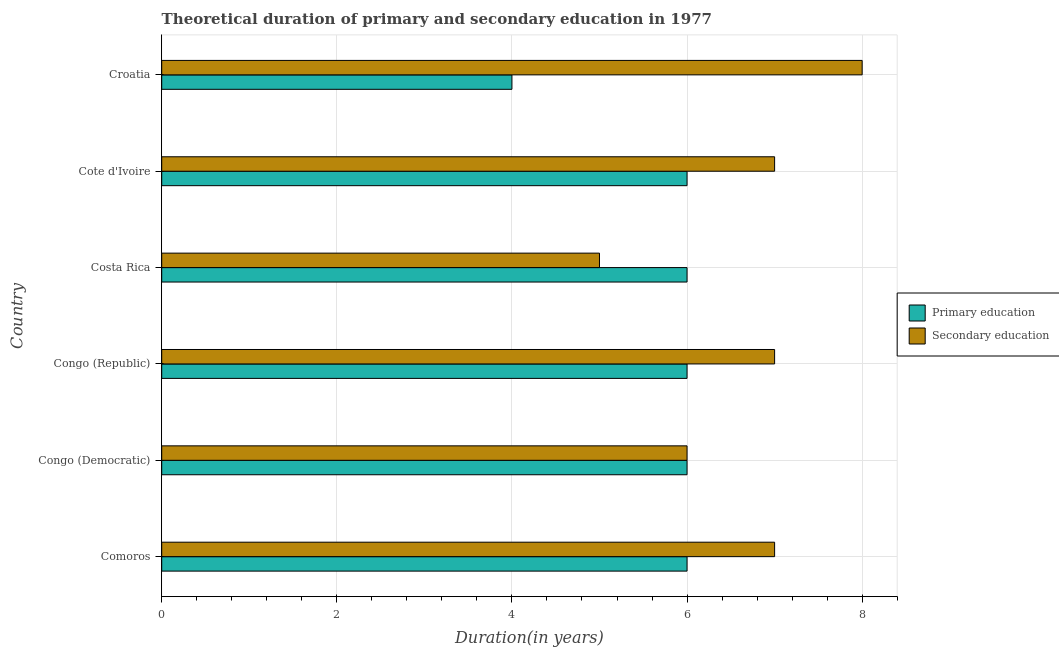How many different coloured bars are there?
Your answer should be compact. 2. How many groups of bars are there?
Offer a very short reply. 6. Are the number of bars per tick equal to the number of legend labels?
Your answer should be very brief. Yes. Are the number of bars on each tick of the Y-axis equal?
Give a very brief answer. Yes. How many bars are there on the 5th tick from the bottom?
Your answer should be compact. 2. What is the label of the 2nd group of bars from the top?
Ensure brevity in your answer.  Cote d'Ivoire. What is the duration of secondary education in Congo (Republic)?
Give a very brief answer. 7. Across all countries, what is the maximum duration of primary education?
Offer a terse response. 6. Across all countries, what is the minimum duration of primary education?
Offer a terse response. 4. In which country was the duration of primary education maximum?
Keep it short and to the point. Comoros. In which country was the duration of secondary education minimum?
Your response must be concise. Costa Rica. What is the total duration of secondary education in the graph?
Offer a very short reply. 40. What is the difference between the duration of primary education in Congo (Democratic) and that in Costa Rica?
Offer a terse response. 0. What is the difference between the duration of secondary education in Costa Rica and the duration of primary education in Croatia?
Provide a short and direct response. 1. What is the average duration of primary education per country?
Your answer should be very brief. 5.67. What is the difference between the duration of secondary education and duration of primary education in Costa Rica?
Ensure brevity in your answer.  -1. In how many countries, is the duration of secondary education greater than 2.8 years?
Provide a succinct answer. 6. Is the difference between the duration of primary education in Congo (Republic) and Cote d'Ivoire greater than the difference between the duration of secondary education in Congo (Republic) and Cote d'Ivoire?
Ensure brevity in your answer.  No. What is the difference between the highest and the second highest duration of secondary education?
Provide a short and direct response. 1. What is the difference between the highest and the lowest duration of primary education?
Provide a short and direct response. 2. What does the 1st bar from the top in Comoros represents?
Provide a short and direct response. Secondary education. How many bars are there?
Your answer should be compact. 12. What is the difference between two consecutive major ticks on the X-axis?
Your answer should be compact. 2. Does the graph contain any zero values?
Provide a short and direct response. No. Does the graph contain grids?
Make the answer very short. Yes. Where does the legend appear in the graph?
Provide a short and direct response. Center right. What is the title of the graph?
Offer a very short reply. Theoretical duration of primary and secondary education in 1977. What is the label or title of the X-axis?
Ensure brevity in your answer.  Duration(in years). What is the Duration(in years) in Primary education in Comoros?
Give a very brief answer. 6. What is the Duration(in years) of Primary education in Congo (Republic)?
Provide a succinct answer. 6. What is the Duration(in years) of Secondary education in Congo (Republic)?
Offer a terse response. 7. What is the Duration(in years) of Secondary education in Costa Rica?
Offer a terse response. 5. What is the Duration(in years) in Primary education in Cote d'Ivoire?
Your response must be concise. 6. What is the Duration(in years) of Secondary education in Cote d'Ivoire?
Make the answer very short. 7. What is the Duration(in years) of Primary education in Croatia?
Your answer should be compact. 4. What is the Duration(in years) of Secondary education in Croatia?
Your answer should be very brief. 8. Across all countries, what is the maximum Duration(in years) of Secondary education?
Offer a terse response. 8. Across all countries, what is the minimum Duration(in years) of Primary education?
Your answer should be compact. 4. What is the difference between the Duration(in years) in Primary education in Comoros and that in Congo (Democratic)?
Offer a very short reply. 0. What is the difference between the Duration(in years) in Secondary education in Comoros and that in Congo (Democratic)?
Make the answer very short. 1. What is the difference between the Duration(in years) of Primary education in Comoros and that in Costa Rica?
Give a very brief answer. 0. What is the difference between the Duration(in years) of Primary education in Comoros and that in Cote d'Ivoire?
Your answer should be compact. 0. What is the difference between the Duration(in years) in Secondary education in Comoros and that in Cote d'Ivoire?
Keep it short and to the point. 0. What is the difference between the Duration(in years) in Secondary education in Comoros and that in Croatia?
Provide a succinct answer. -1. What is the difference between the Duration(in years) in Primary education in Congo (Democratic) and that in Congo (Republic)?
Provide a succinct answer. 0. What is the difference between the Duration(in years) in Secondary education in Congo (Democratic) and that in Congo (Republic)?
Make the answer very short. -1. What is the difference between the Duration(in years) in Secondary education in Congo (Democratic) and that in Costa Rica?
Offer a very short reply. 1. What is the difference between the Duration(in years) of Primary education in Congo (Democratic) and that in Cote d'Ivoire?
Provide a succinct answer. 0. What is the difference between the Duration(in years) in Secondary education in Congo (Democratic) and that in Cote d'Ivoire?
Offer a terse response. -1. What is the difference between the Duration(in years) of Primary education in Congo (Republic) and that in Costa Rica?
Ensure brevity in your answer.  0. What is the difference between the Duration(in years) of Primary education in Congo (Republic) and that in Cote d'Ivoire?
Ensure brevity in your answer.  0. What is the difference between the Duration(in years) in Secondary education in Congo (Republic) and that in Croatia?
Offer a terse response. -1. What is the difference between the Duration(in years) of Primary education in Costa Rica and that in Cote d'Ivoire?
Provide a succinct answer. 0. What is the difference between the Duration(in years) of Secondary education in Costa Rica and that in Cote d'Ivoire?
Your answer should be very brief. -2. What is the difference between the Duration(in years) in Secondary education in Costa Rica and that in Croatia?
Ensure brevity in your answer.  -3. What is the difference between the Duration(in years) of Secondary education in Cote d'Ivoire and that in Croatia?
Make the answer very short. -1. What is the difference between the Duration(in years) of Primary education in Comoros and the Duration(in years) of Secondary education in Congo (Republic)?
Offer a terse response. -1. What is the difference between the Duration(in years) in Primary education in Comoros and the Duration(in years) in Secondary education in Costa Rica?
Your answer should be very brief. 1. What is the difference between the Duration(in years) of Primary education in Comoros and the Duration(in years) of Secondary education in Croatia?
Offer a terse response. -2. What is the difference between the Duration(in years) in Primary education in Congo (Democratic) and the Duration(in years) in Secondary education in Congo (Republic)?
Give a very brief answer. -1. What is the difference between the Duration(in years) of Primary education in Congo (Democratic) and the Duration(in years) of Secondary education in Costa Rica?
Your answer should be compact. 1. What is the difference between the Duration(in years) of Primary education in Congo (Democratic) and the Duration(in years) of Secondary education in Cote d'Ivoire?
Give a very brief answer. -1. What is the difference between the Duration(in years) in Primary education in Costa Rica and the Duration(in years) in Secondary education in Cote d'Ivoire?
Keep it short and to the point. -1. What is the difference between the Duration(in years) of Primary education in Costa Rica and the Duration(in years) of Secondary education in Croatia?
Make the answer very short. -2. What is the average Duration(in years) in Primary education per country?
Your answer should be very brief. 5.67. What is the average Duration(in years) in Secondary education per country?
Provide a succinct answer. 6.67. What is the difference between the Duration(in years) in Primary education and Duration(in years) in Secondary education in Comoros?
Make the answer very short. -1. What is the difference between the Duration(in years) in Primary education and Duration(in years) in Secondary education in Congo (Democratic)?
Make the answer very short. 0. What is the difference between the Duration(in years) of Primary education and Duration(in years) of Secondary education in Congo (Republic)?
Give a very brief answer. -1. What is the difference between the Duration(in years) of Primary education and Duration(in years) of Secondary education in Costa Rica?
Your response must be concise. 1. What is the difference between the Duration(in years) of Primary education and Duration(in years) of Secondary education in Cote d'Ivoire?
Provide a short and direct response. -1. What is the ratio of the Duration(in years) in Primary education in Comoros to that in Congo (Democratic)?
Keep it short and to the point. 1. What is the ratio of the Duration(in years) of Primary education in Comoros to that in Congo (Republic)?
Offer a very short reply. 1. What is the ratio of the Duration(in years) in Secondary education in Comoros to that in Congo (Republic)?
Offer a terse response. 1. What is the ratio of the Duration(in years) of Secondary education in Comoros to that in Costa Rica?
Offer a terse response. 1.4. What is the ratio of the Duration(in years) of Primary education in Comoros to that in Cote d'Ivoire?
Give a very brief answer. 1. What is the ratio of the Duration(in years) of Secondary education in Comoros to that in Cote d'Ivoire?
Your response must be concise. 1. What is the ratio of the Duration(in years) of Secondary education in Comoros to that in Croatia?
Make the answer very short. 0.88. What is the ratio of the Duration(in years) of Secondary education in Congo (Democratic) to that in Cote d'Ivoire?
Give a very brief answer. 0.86. What is the ratio of the Duration(in years) of Secondary education in Congo (Democratic) to that in Croatia?
Provide a succinct answer. 0.75. What is the ratio of the Duration(in years) of Primary education in Congo (Republic) to that in Costa Rica?
Provide a succinct answer. 1. What is the ratio of the Duration(in years) in Secondary education in Congo (Republic) to that in Costa Rica?
Offer a very short reply. 1.4. What is the ratio of the Duration(in years) of Primary education in Congo (Republic) to that in Croatia?
Your answer should be very brief. 1.5. What is the ratio of the Duration(in years) of Secondary education in Congo (Republic) to that in Croatia?
Your answer should be very brief. 0.88. What is the ratio of the Duration(in years) of Primary education in Costa Rica to that in Cote d'Ivoire?
Offer a very short reply. 1. What is the ratio of the Duration(in years) of Primary education in Costa Rica to that in Croatia?
Your response must be concise. 1.5. What is the ratio of the Duration(in years) in Secondary education in Costa Rica to that in Croatia?
Your answer should be compact. 0.62. What is the ratio of the Duration(in years) of Secondary education in Cote d'Ivoire to that in Croatia?
Provide a succinct answer. 0.88. What is the difference between the highest and the second highest Duration(in years) of Primary education?
Keep it short and to the point. 0. What is the difference between the highest and the lowest Duration(in years) of Primary education?
Ensure brevity in your answer.  2. 